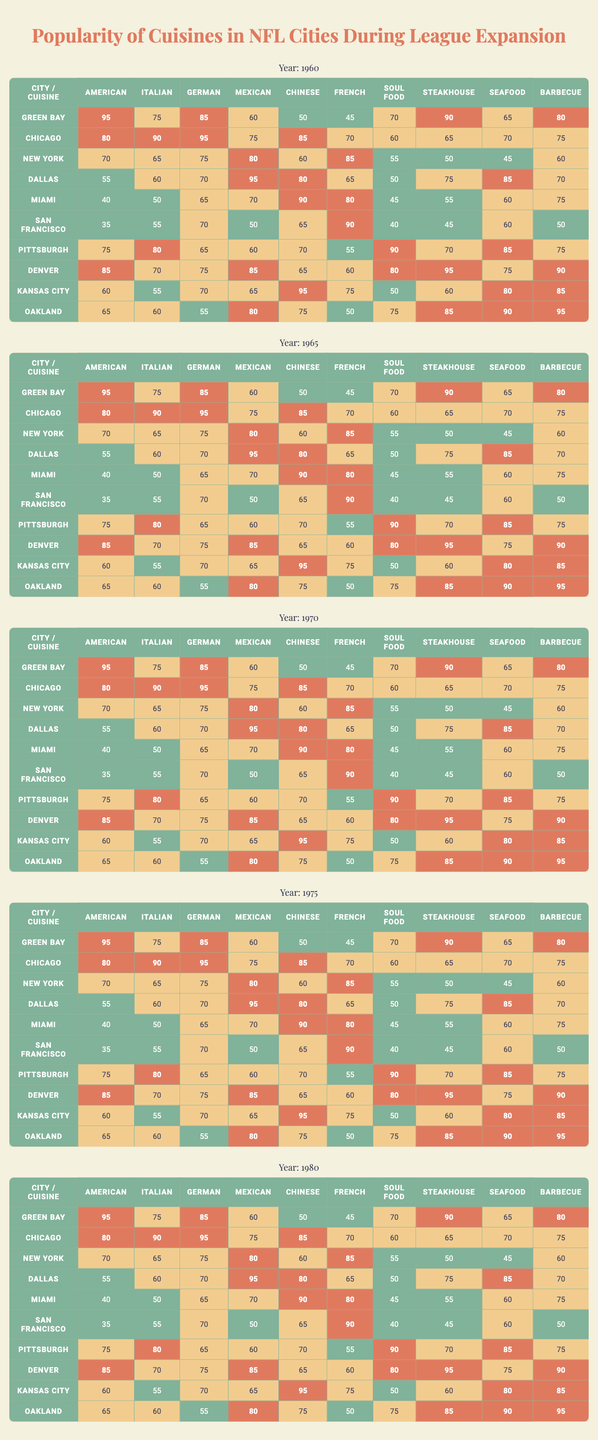What city has the highest score for American cuisine in 1970? Looking at the data for the year 1970, the scores for American cuisine show that Green Bay has the highest score of 95.
Answer: Green Bay Which cuisine scored the lowest in Miami in 1980? In Miami for the year 1980, the scores show that American cuisine had the lowest score of 40.
Answer: American What is the average score of Italian cuisine across all cities in 1965? Adding the scores for Italian cuisine in 1965: (75 + 90 + 65 + 60 + 50 + 55 + 80 + 70 + 55 + 60) = 600. There are 10 cities, so the average is 600/10 = 60.
Answer: 60 Did any city score over 90 for Seafood in 1975? The scores for Seafood in 1975 indicate that the highest score is 95, which is recorded for San Francisco. So, yes, there is a city with a score over 90.
Answer: Yes Which cuisine is consistently popular (score of 70 or above) in all cities for the year 1970? Analyzing the scores for 1970, Chinese cuisine scores are 75, 95, 80, 70, 90, 70, 65, 75, 70, and 55. Not all cities scored 70 or above, so no cuisine is consistently popular in that year.
Answer: No What is the difference in popularity scores for Barbecue cuisine between Pittsburgh and Kansas City in 1980? For Barbecue cuisine, Pittsburgh scored 70 and Kansas City scored 75 in 1980. The difference is 75 - 70 = 5.
Answer: 5 Is it true that Chicago scored the highest overall popularity in 1965? The scores for Chicago in 1965 across all cuisines shows a maximum of 90 (for Italian cuisine), but not the highest overall score when compared to other cities across all cuisines. Therefore, it is false.
Answer: No Which city had the largest score gap between 1960 and 1980 for Mexican cuisine? Evaluating the Mexican cuisine scores, Green Bay had 60 in 1960 and 70 in 1980—a gap of 10. On the other hand, Kansas City had 65 in 1960 and 85 in 1980, leading to a gap of 20. Thus, Kansas City had the largest gap.
Answer: Kansas City What is the median score for Steakhouse cuisine across all cities in 1975? The scores for Steakhouse in 1975 are 90, 65, 50, 75, 60, 45, 70, 95, 60, and 85. Arranging these scores in ascending order gives us 45, 50, 60, 60, 65, 70, 75, 85, 90, 95. The median score is the average of the 5th and 6th scores: (65 + 70) / 2 = 67.5.
Answer: 67.5 Which cuisines had a score of 50 or lower in Oakland in any year? Checking Oakland's scores across all years, we see that Barbecue in 1960 had a score of 50, and Chinese had a score of 50 in 1970. Therefore, these cuisines had a score of 50 or lower.
Answer: Barbecue, Chinese 